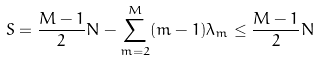Convert formula to latex. <formula><loc_0><loc_0><loc_500><loc_500>S = \frac { M - 1 } { 2 } N - \sum _ { m = 2 } ^ { M } ( m - 1 ) \lambda _ { m } \leq \frac { M - 1 } { 2 } N</formula> 